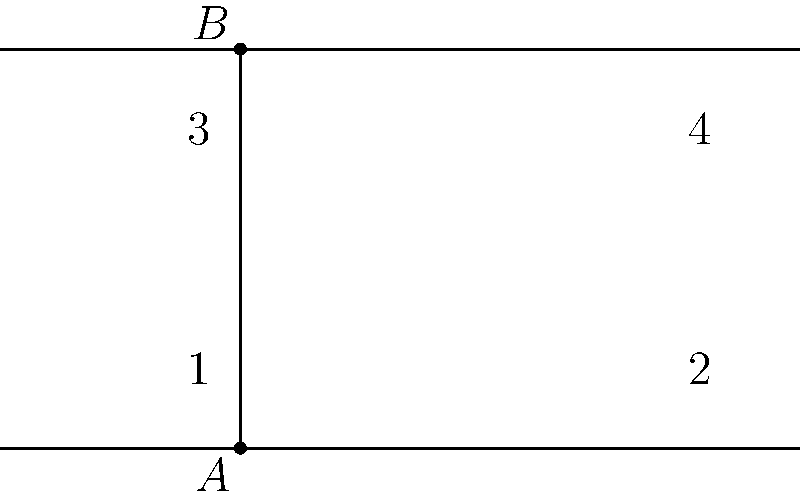Ladies and gentlemen, we have a captivating geometric scenario before us! Imagine two parallel lines, cut by a third line that's bold enough to cross both. Now, here's the million-dollar question: If angle 1 measures 65 degrees, what's the measure of angle 3? Is it the same, different, or perhaps there's a hidden twist? Let's dive into this angular mystery! Alright, let's unravel this geometric puzzle step by step:

1) First, we need to recall a fundamental principle in geometry: when a line intersects two parallel lines, it forms corresponding angles that are equal. This is like a universal law in the world of parallel lines!

2) In our diagram, angles 1 and 3 are corresponding angles. They're in the same position relative to the intersecting line and the parallel lines. It's like they're mirror images of each other!

3) Now, we're told that angle 1 measures 65 degrees. Given the principle we just discussed, what do you think this means for angle 3?

4) That's right! Angle 3 must also measure 65 degrees. It's not just similar, it's identical!

5) This isn't just a coincidence. It's a rock-solid geometric fact. No matter where you draw that intersecting line, corresponding angles will always be equal when it comes to parallel lines.

So, there you have it! The measure of angle 3 is the same as angle 1, a perfect 65 degrees. It's like these angles are twins, always matching each other in perfect harmony!
Answer: $65°$ 